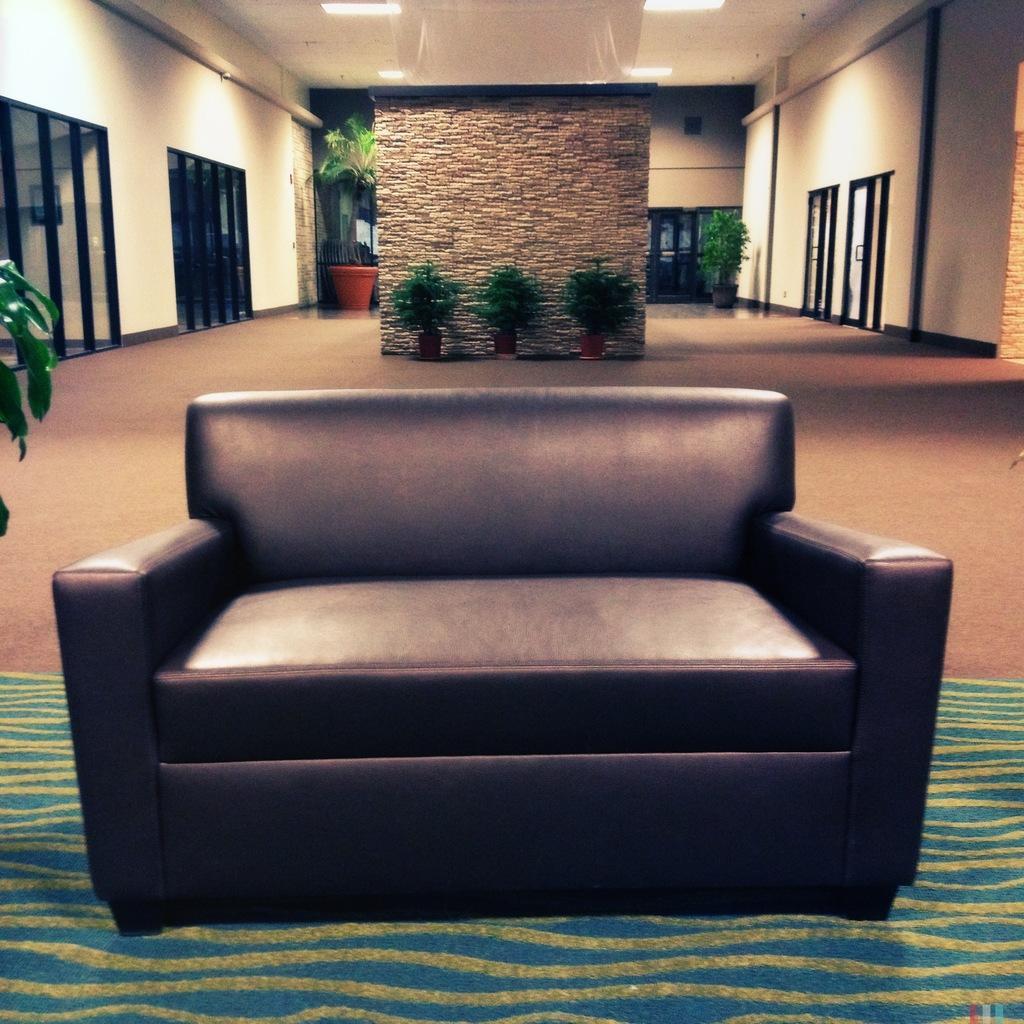Describe this image in one or two sentences. In this image there is a sofa. There is a blue color carpet. There are tree pots. There is a wall with the glasses on the both sides. There is a roof with the lights. 